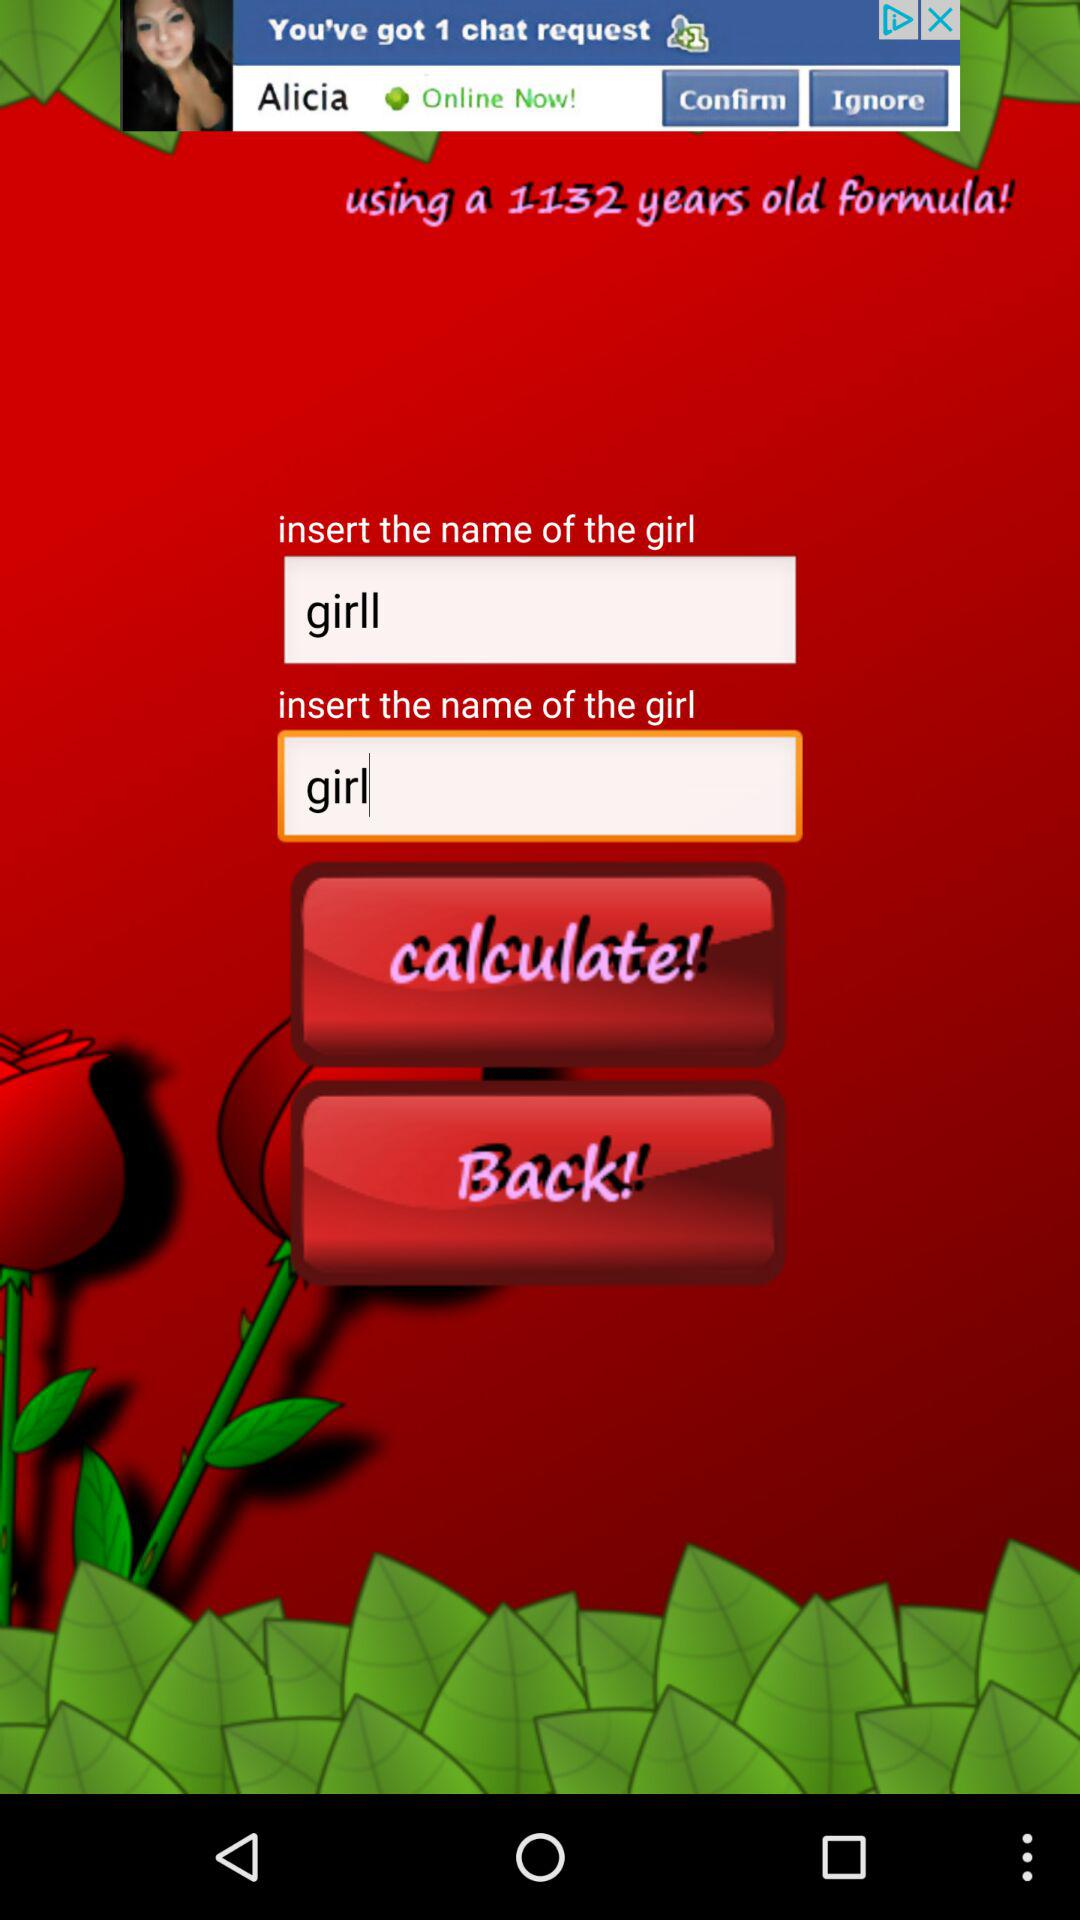What name have inserted for "girl"? The insterted names are "girll" and "girl". 